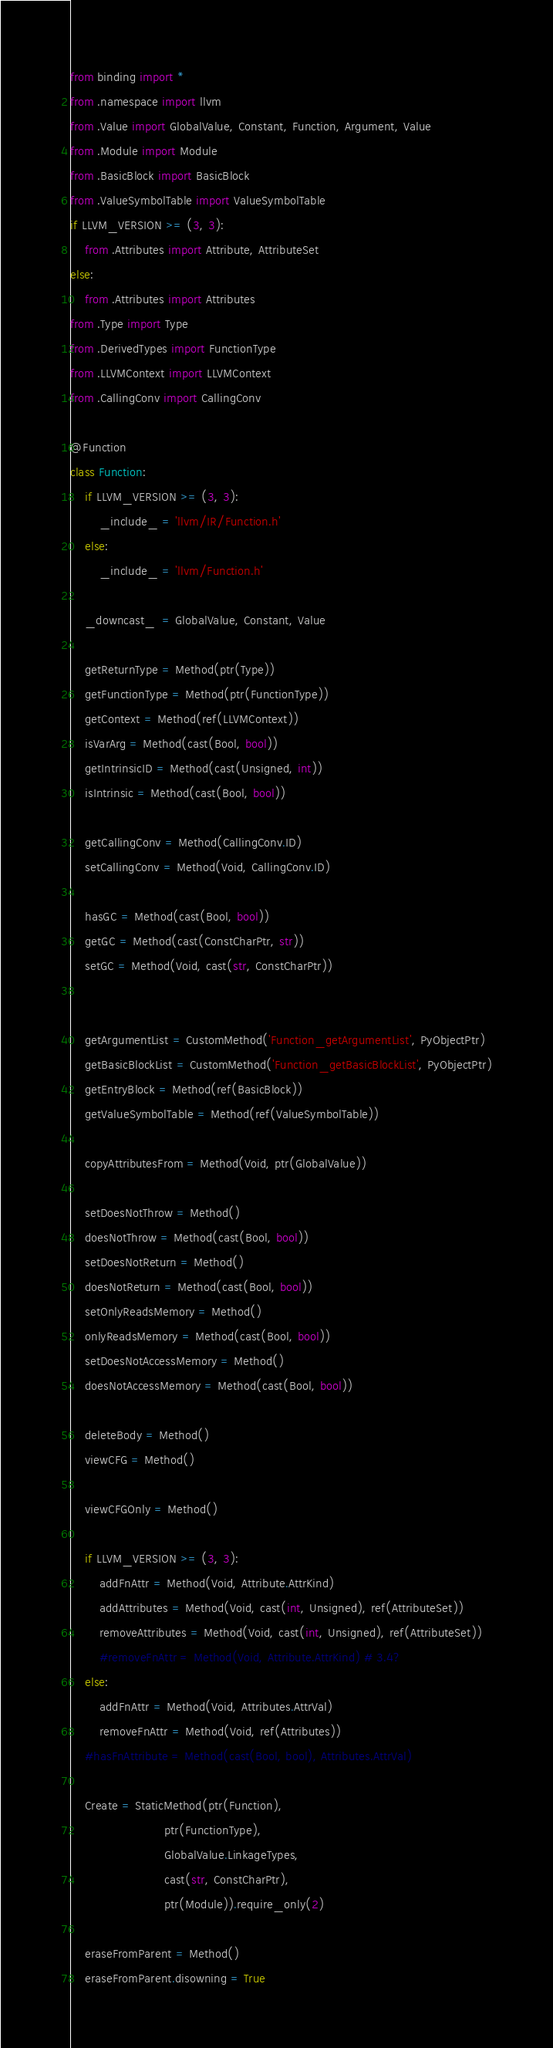Convert code to text. <code><loc_0><loc_0><loc_500><loc_500><_Python_>from binding import *
from .namespace import llvm
from .Value import GlobalValue, Constant, Function, Argument, Value
from .Module import Module
from .BasicBlock import BasicBlock
from .ValueSymbolTable import ValueSymbolTable
if LLVM_VERSION >= (3, 3):
    from .Attributes import Attribute, AttributeSet
else:
    from .Attributes import Attributes
from .Type import Type
from .DerivedTypes import FunctionType
from .LLVMContext import LLVMContext
from .CallingConv import CallingConv

@Function
class Function:
    if LLVM_VERSION >= (3, 3):
        _include_ = 'llvm/IR/Function.h'
    else:
        _include_ = 'llvm/Function.h'

    _downcast_  = GlobalValue, Constant, Value

    getReturnType = Method(ptr(Type))
    getFunctionType = Method(ptr(FunctionType))
    getContext = Method(ref(LLVMContext))
    isVarArg = Method(cast(Bool, bool))
    getIntrinsicID = Method(cast(Unsigned, int))
    isIntrinsic = Method(cast(Bool, bool))

    getCallingConv = Method(CallingConv.ID)
    setCallingConv = Method(Void, CallingConv.ID)

    hasGC = Method(cast(Bool, bool))
    getGC = Method(cast(ConstCharPtr, str))
    setGC = Method(Void, cast(str, ConstCharPtr))


    getArgumentList = CustomMethod('Function_getArgumentList', PyObjectPtr)
    getBasicBlockList = CustomMethod('Function_getBasicBlockList', PyObjectPtr)
    getEntryBlock = Method(ref(BasicBlock))
    getValueSymbolTable = Method(ref(ValueSymbolTable))

    copyAttributesFrom = Method(Void, ptr(GlobalValue))

    setDoesNotThrow = Method()
    doesNotThrow = Method(cast(Bool, bool))
    setDoesNotReturn = Method()
    doesNotReturn = Method(cast(Bool, bool))
    setOnlyReadsMemory = Method()
    onlyReadsMemory = Method(cast(Bool, bool))
    setDoesNotAccessMemory = Method()
    doesNotAccessMemory = Method(cast(Bool, bool))

    deleteBody = Method()
    viewCFG = Method()

    viewCFGOnly = Method()

    if LLVM_VERSION >= (3, 3):
        addFnAttr = Method(Void, Attribute.AttrKind)
        addAttributes = Method(Void, cast(int, Unsigned), ref(AttributeSet))
        removeAttributes = Method(Void, cast(int, Unsigned), ref(AttributeSet))
        #removeFnAttr = Method(Void, Attribute.AttrKind) # 3.4?
    else:
        addFnAttr = Method(Void, Attributes.AttrVal)
        removeFnAttr = Method(Void, ref(Attributes))
    #hasFnAttribute = Method(cast(Bool, bool), Attributes.AttrVal)

    Create = StaticMethod(ptr(Function),
                          ptr(FunctionType),
                          GlobalValue.LinkageTypes,
                          cast(str, ConstCharPtr),
                          ptr(Module)).require_only(2)

    eraseFromParent = Method()
    eraseFromParent.disowning = True

</code> 